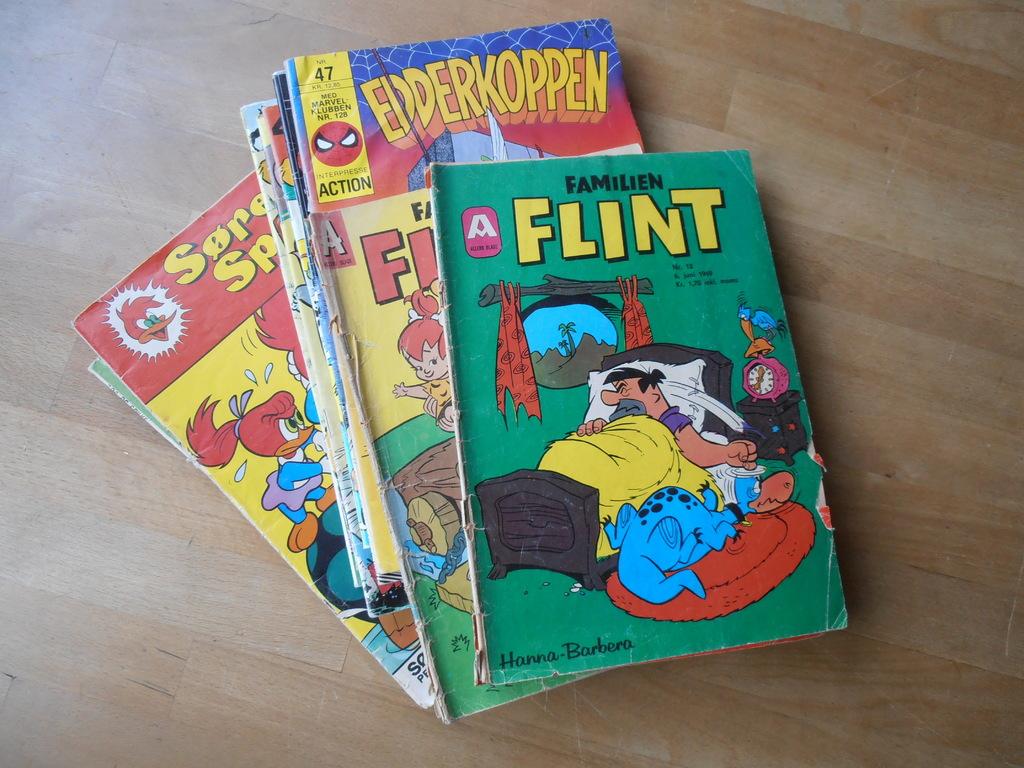What publisher is on the bottom left of the green book?
Your answer should be compact. Hanna-barbera. What is the name of the top comic book?
Provide a succinct answer. Flint. 